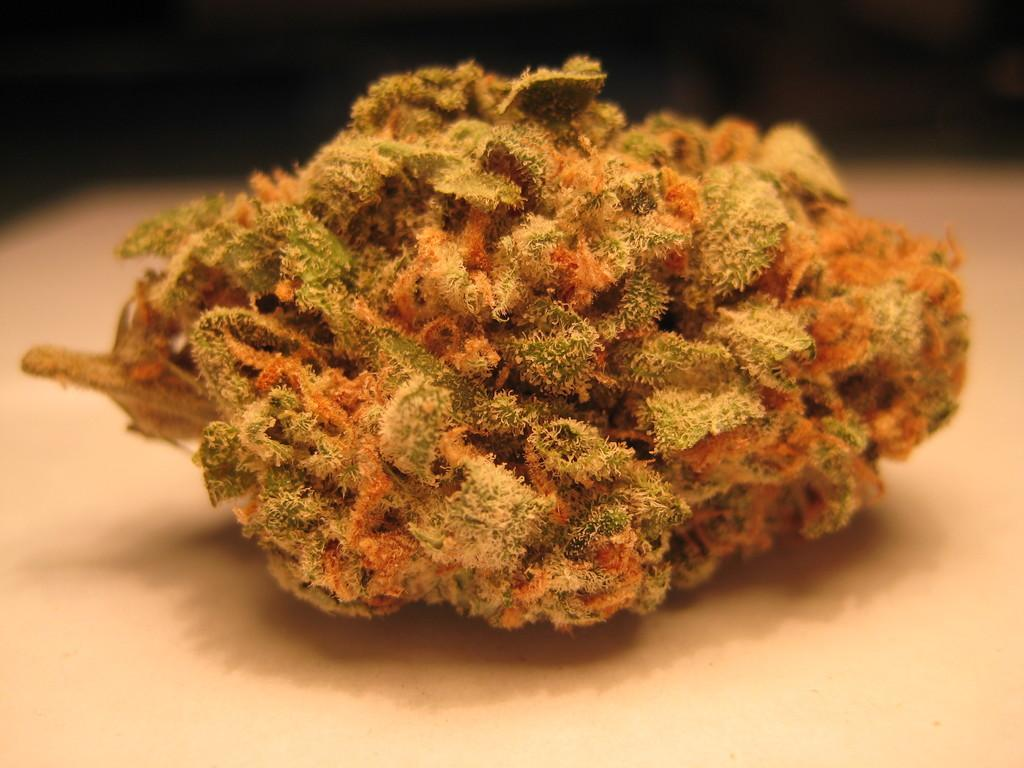How does the idea of using a toothbrush during winter help in understanding the image? The image does not contain any information about ideas, toothbrushes, or winter, so these concepts do not help in understanding the image. How does the idea of using a toothbrush during winter help in understanding the image? The image does not contain any information about ideas, toothbrushes, or winter, so these concepts do not help in understanding the image. 